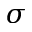Convert formula to latex. <formula><loc_0><loc_0><loc_500><loc_500>\sigma</formula> 